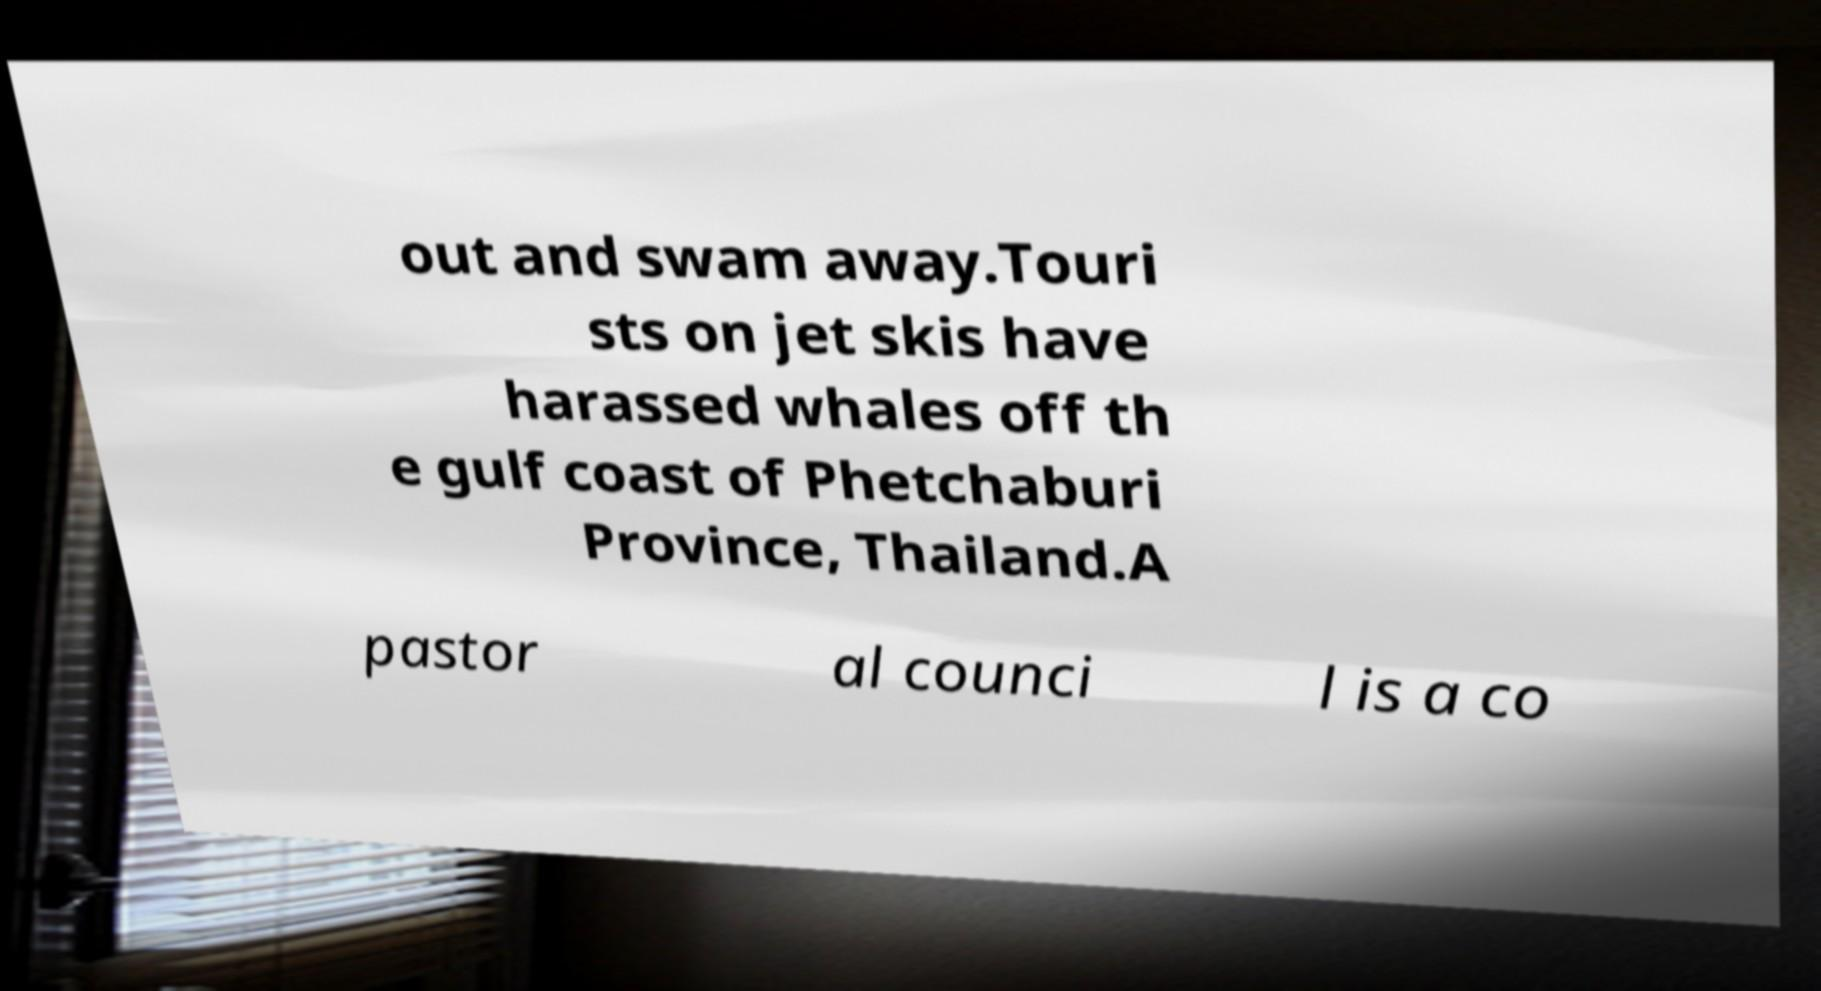Please read and relay the text visible in this image. What does it say? out and swam away.Touri sts on jet skis have harassed whales off th e gulf coast of Phetchaburi Province, Thailand.A pastor al counci l is a co 